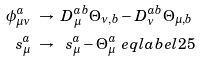<formula> <loc_0><loc_0><loc_500><loc_500>\phi _ { \mu \nu } ^ { a } & \ \to \ D _ { \mu } ^ { a b } \Theta _ { \nu , b } - D _ { \nu } ^ { a b } \Theta _ { \mu , b } \\ \ s _ { \mu } ^ { a } & \ \to \ \ s _ { \mu } ^ { a } - \Theta _ { \mu } ^ { a } \ e q l a b e l { 2 5 }</formula> 